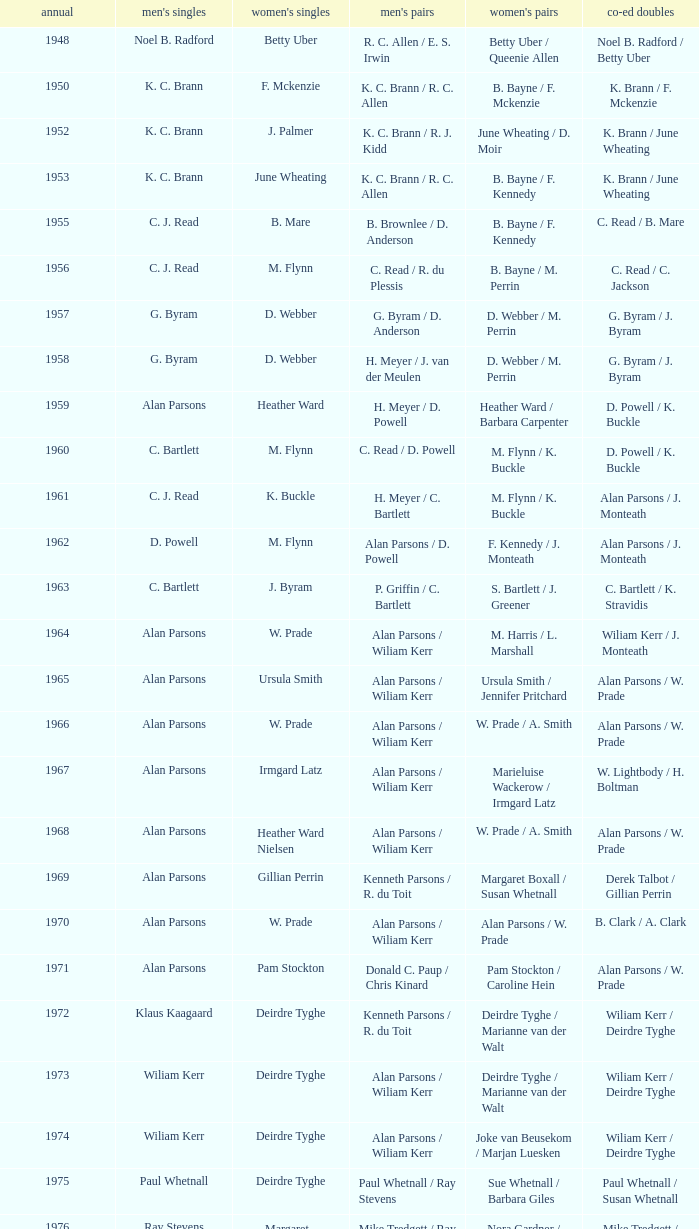Which Men's doubles have a Year smaller than 1960, and Men's singles of noel b. radford? R. C. Allen / E. S. Irwin. Could you parse the entire table? {'header': ['annual', "men's singles", "women's singles", "men's pairs", "women's pairs", 'co-ed doubles'], 'rows': [['1948', 'Noel B. Radford', 'Betty Uber', 'R. C. Allen / E. S. Irwin', 'Betty Uber / Queenie Allen', 'Noel B. Radford / Betty Uber'], ['1950', 'K. C. Brann', 'F. Mckenzie', 'K. C. Brann / R. C. Allen', 'B. Bayne / F. Mckenzie', 'K. Brann / F. Mckenzie'], ['1952', 'K. C. Brann', 'J. Palmer', 'K. C. Brann / R. J. Kidd', 'June Wheating / D. Moir', 'K. Brann / June Wheating'], ['1953', 'K. C. Brann', 'June Wheating', 'K. C. Brann / R. C. Allen', 'B. Bayne / F. Kennedy', 'K. Brann / June Wheating'], ['1955', 'C. J. Read', 'B. Mare', 'B. Brownlee / D. Anderson', 'B. Bayne / F. Kennedy', 'C. Read / B. Mare'], ['1956', 'C. J. Read', 'M. Flynn', 'C. Read / R. du Plessis', 'B. Bayne / M. Perrin', 'C. Read / C. Jackson'], ['1957', 'G. Byram', 'D. Webber', 'G. Byram / D. Anderson', 'D. Webber / M. Perrin', 'G. Byram / J. Byram'], ['1958', 'G. Byram', 'D. Webber', 'H. Meyer / J. van der Meulen', 'D. Webber / M. Perrin', 'G. Byram / J. Byram'], ['1959', 'Alan Parsons', 'Heather Ward', 'H. Meyer / D. Powell', 'Heather Ward / Barbara Carpenter', 'D. Powell / K. Buckle'], ['1960', 'C. Bartlett', 'M. Flynn', 'C. Read / D. Powell', 'M. Flynn / K. Buckle', 'D. Powell / K. Buckle'], ['1961', 'C. J. Read', 'K. Buckle', 'H. Meyer / C. Bartlett', 'M. Flynn / K. Buckle', 'Alan Parsons / J. Monteath'], ['1962', 'D. Powell', 'M. Flynn', 'Alan Parsons / D. Powell', 'F. Kennedy / J. Monteath', 'Alan Parsons / J. Monteath'], ['1963', 'C. Bartlett', 'J. Byram', 'P. Griffin / C. Bartlett', 'S. Bartlett / J. Greener', 'C. Bartlett / K. Stravidis'], ['1964', 'Alan Parsons', 'W. Prade', 'Alan Parsons / Wiliam Kerr', 'M. Harris / L. Marshall', 'Wiliam Kerr / J. Monteath'], ['1965', 'Alan Parsons', 'Ursula Smith', 'Alan Parsons / Wiliam Kerr', 'Ursula Smith / Jennifer Pritchard', 'Alan Parsons / W. Prade'], ['1966', 'Alan Parsons', 'W. Prade', 'Alan Parsons / Wiliam Kerr', 'W. Prade / A. Smith', 'Alan Parsons / W. Prade'], ['1967', 'Alan Parsons', 'Irmgard Latz', 'Alan Parsons / Wiliam Kerr', 'Marieluise Wackerow / Irmgard Latz', 'W. Lightbody / H. Boltman'], ['1968', 'Alan Parsons', 'Heather Ward Nielsen', 'Alan Parsons / Wiliam Kerr', 'W. Prade / A. Smith', 'Alan Parsons / W. Prade'], ['1969', 'Alan Parsons', 'Gillian Perrin', 'Kenneth Parsons / R. du Toit', 'Margaret Boxall / Susan Whetnall', 'Derek Talbot / Gillian Perrin'], ['1970', 'Alan Parsons', 'W. Prade', 'Alan Parsons / Wiliam Kerr', 'Alan Parsons / W. Prade', 'B. Clark / A. Clark'], ['1971', 'Alan Parsons', 'Pam Stockton', 'Donald C. Paup / Chris Kinard', 'Pam Stockton / Caroline Hein', 'Alan Parsons / W. Prade'], ['1972', 'Klaus Kaagaard', 'Deirdre Tyghe', 'Kenneth Parsons / R. du Toit', 'Deirdre Tyghe / Marianne van der Walt', 'Wiliam Kerr / Deirdre Tyghe'], ['1973', 'Wiliam Kerr', 'Deirdre Tyghe', 'Alan Parsons / Wiliam Kerr', 'Deirdre Tyghe / Marianne van der Walt', 'Wiliam Kerr / Deirdre Tyghe'], ['1974', 'Wiliam Kerr', 'Deirdre Tyghe', 'Alan Parsons / Wiliam Kerr', 'Joke van Beusekom / Marjan Luesken', 'Wiliam Kerr / Deirdre Tyghe'], ['1975', 'Paul Whetnall', 'Deirdre Tyghe', 'Paul Whetnall / Ray Stevens', 'Sue Whetnall / Barbara Giles', 'Paul Whetnall / Susan Whetnall'], ['1976', 'Ray Stevens', 'Margaret Lockwood', 'Mike Tredgett / Ray Stevens', 'Nora Gardner / Margaret Lockwood', 'Mike Tredgett / Nora Gardner'], ['1977', 'Wiliam Kerr', 'Deirdre Algie', 'Kenneth Parsons / Wiliam Kerr', 'Gussie Botes / Marianne van der Walt', 'Kenneth Parsons / Deirdre Algie'], ['1978', 'Gordon McMillan', 'Deirdre Algie', 'Gordon McMillan / John Abrahams', 'Gussie Botes / Marianne Abrahams', 'Kenneth Parsons / Deirdre Algie'], ['1979', 'Johan Croukamp', 'Gussie Botes', 'Gordon McMillan / John Abrahams', 'Gussie Botes / Marianne Abrahams', 'Alan Phillips / Gussie Botes'], ['1980', 'Chris Kinard', 'Utami Kinard', 'Alan Phillips / Kenneth Parsons', 'Gussie Phillips / Marianne Abrahams', 'Alan Phillips / Gussie Phillips'], ['1981', 'Johan Bosman', 'Deirdre Algie', 'Alan Phillips / Kenneth Parsons', 'Deirdre Algie / Karen Glenister', 'Alan Phillips / Gussie Phillips'], ['1982', 'Alan Phillips', 'Gussie Phillips', 'Alan Phillips / Kenneth Parsons', 'Gussie Phillips / Tracey Phillips', 'Alan Phillips / Gussie Phillips'], ['1983', 'Johan Croukamp', 'Gussie Phillips', 'Alan Phillips / David Phillips', 'Gussie Phillips / Tracey Phillips', 'Alan Phillips / Gussie Phillips'], ['1984', 'Johan Croukamp', 'Karen Glenister', 'Alan Phillips / David Phillips', 'Gussie Phillips / Tracey Phillips', 'Alan Phillips / Gussie Phillips'], ['1985', 'Johan Bosman', 'Gussie Phillips', 'Alan Phillips / David Phillips', 'Deirdre Algie / L. Humphrey', 'Alan Phillips / Gussie Phillips'], ['1986', 'Johan Bosman', 'Vanessa van der Walt', 'Alan Phillips / David Phillips', 'Gussie Phillips / Tracey Thompson', 'Alan Phillips / Gussie Phillips'], ['1987', 'Johan Bosman', 'Gussie Phillips', 'Alan Phillips / David Phillips', 'Gussie Phillips / Tracey Thompson', 'Alan Phillips / Gussie Phillips'], ['1988', 'Alan Phillips', 'Gussie Phillips', 'Alan Phillips / David Phillips', 'Gussie Phillips / Tracey Thompson', 'Alan Phillips / Gussie Phillips'], ['1989', 'Alan Phillips', 'Lina Fourie', 'Kenneth Parsons / Nico Meerholz', 'Gussie Phillips / Tracey Thompson', 'Alan Phillips / Gussie Phillips'], ['1990', 'Alan Phillips', 'Lina Fourie', 'Anton Kriel / Nico Meerholz', 'Gussie Phillips / Tracey Thompson', 'Alan Phillips / Gussie Phillips'], ['1991', 'Anton Kriel', 'Lina Fourie', 'Anton Kriel / Nico Meerholz', 'Lina Fourie / E. Fourie', 'Anton Kriel / Vanessa van der Walt'], ['1992', 'D. Plasson', 'Lina Fourie', 'Anton Kriel / Nico Meerholz', 'Gussie Phillips / Tracey Thompson', 'Anton Kriel / Vanessa van der Walt'], ['1993', 'Johan Kleingeld', 'Lina Fourie', 'Anton Kriel / Nico Meerholz', 'Gussie Phillips / Tracey Thompson', 'Johan Kleingeld / Lina Fourie'], ['1994', 'Johan Kleingeld', 'Lina Fourie', 'Anton Kriel / Nico Meerholz', 'Lina Fourie / Beverley Meerholz', 'Johan Kleingeld / Lina Fourie'], ['1995', 'Johan Kleingeld', 'Lina Fourie', 'Johan Kleingeld / Gavin Polmans', 'L. Humphrey / Monique Till', 'Alan Phillips / Gussie Phillips'], ['1996', 'Warren Parsons', 'Lina Fourie', 'Johan Kleingeld / Gavin Polmans', 'Linda Montignies / Monique Till', 'Anton Kriel / Vanessa van der Walt'], ['1997', 'Johan Kleingeld', 'Lina Fourie', 'Warren Parsons / Neale Woodroffe', 'Lina Fourie / Tracey Thompson', 'Johan Kleingeld / Lina Fourie'], ['1998', 'Johan Kleingeld', 'Lina Fourie', 'Gavin Polmans / Neale Woodroffe', 'Linda Montignies / Monique Ric-Hansen', 'Anton Kriel / Michelle Edwards'], ['1999', 'Michael Adams', 'Lina Fourie', 'Johan Kleingeld / Anton Kriel', 'Linda Montignies / Monique Ric-Hansen', 'Johan Kleingeld / Karen Coetzer'], ['2000', 'Michael Adams', 'Michelle Edwards', 'Nico Meerholz / Anton Kriel', 'Lina Fourie / Karen Coetzer', 'Anton Kriel / Michelle Edwards'], ['2001', 'Stewart Carson', 'Michelle Edwards', 'Chris Dednam / Johan Kleingeld', 'Lina Fourie / Karen Coetzer', 'Chris Dednam / Antoinette Uys'], ['2002', 'Stewart Carson', 'Michelle Edwards', 'Chris Dednam / Johan Kleingeld', 'Michelle Edwards / Chantal Botts', 'Johan Kleingeld / Marika Daubern'], ['2003', 'Chris Dednam', 'Michelle Edwards', 'Chris Dednam / Johan Kleingeld', 'Michelle Edwards / Chantal Botts', 'Johan Kleingeld / Marika Daubern'], ['2004', 'Chris Dednam', 'Michelle Edwards', 'Chris Dednam / Roelof Dednam', 'Michelle Edwards / Chantal Botts', 'Dorian James / Michelle Edwards'], ['2005', 'Chris Dednam', 'Marika Daubern', 'Chris Dednam / Roelof Dednam', 'Marika Daubern / Kerry Lee Harrington', 'Johan Kleingeld / Marika Daubern'], ['2006', 'Chris Dednam', 'Kerry Lee Harrington', 'Chris Dednam / Roelof Dednam', 'Michelle Edwards / Chantal Botts', 'Dorian James / Michelle Edwards'], ['2007', 'Wiaan Viljoen', 'Stacey Doubell', 'Chris Dednam / Roelof Dednam', 'Michelle Edwards / Chantal Botts', 'Dorian James / Michelle Edwards'], ['2008', 'Chris Dednam', 'Stacey Doubell', 'Chris Dednam / Roelof Dednam', 'Michelle Edwards / Chantal Botts', 'Chris Dednam / Michelle Edwards'], ['2009', 'Roelof Dednam', 'Kerry Lee Harrington', 'Dorian James / Wiaan Viljoen', 'Michelle Edwards / Annari Viljoen', 'Chris Dednam / Annari Viljoen']]} 